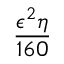Convert formula to latex. <formula><loc_0><loc_0><loc_500><loc_500>\frac { \epsilon ^ { 2 } \eta } { 1 6 0 }</formula> 